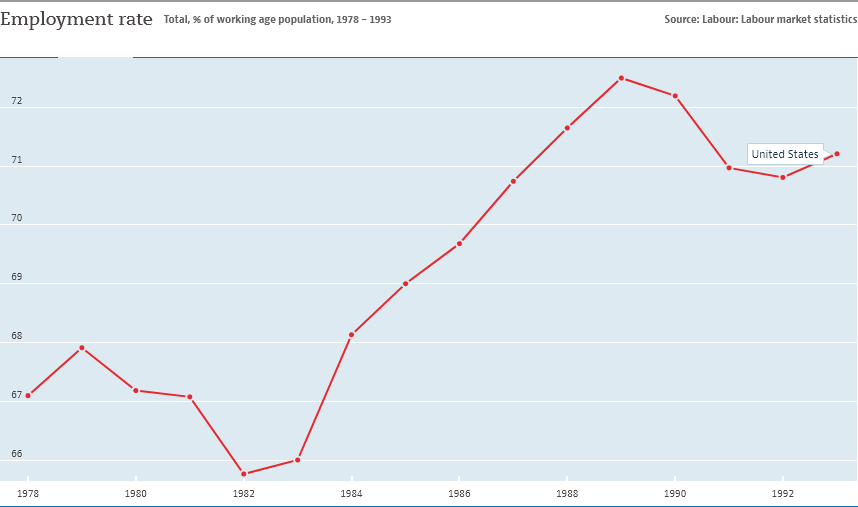Give some essential details in this illustration. In 1982, the employment rate in the United States reached its lowest point. The graph displays a line with the color red representing a country. The country represented by the red color line is the United States. 